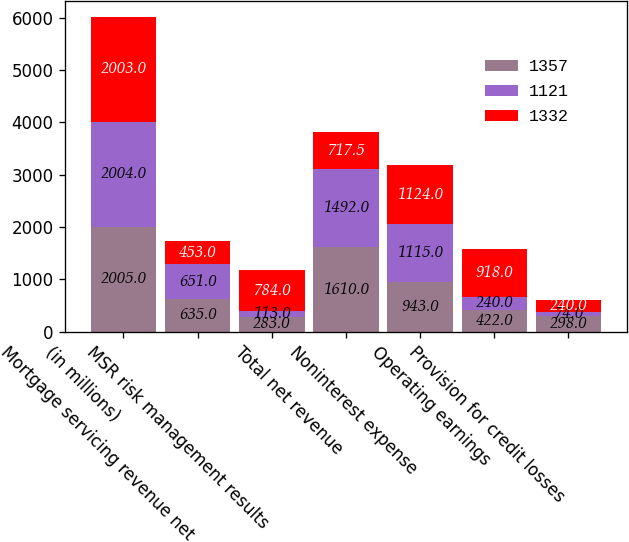Convert chart to OTSL. <chart><loc_0><loc_0><loc_500><loc_500><stacked_bar_chart><ecel><fcel>(in millions)<fcel>Mortgage servicing revenue net<fcel>MSR risk management results<fcel>Total net revenue<fcel>Noninterest expense<fcel>Operating earnings<fcel>Provision for credit losses<nl><fcel>1357<fcel>2005<fcel>635<fcel>283<fcel>1610<fcel>943<fcel>422<fcel>298<nl><fcel>1121<fcel>2004<fcel>651<fcel>113<fcel>1492<fcel>1115<fcel>240<fcel>74<nl><fcel>1332<fcel>2003<fcel>453<fcel>784<fcel>717.5<fcel>1124<fcel>918<fcel>240<nl></chart> 